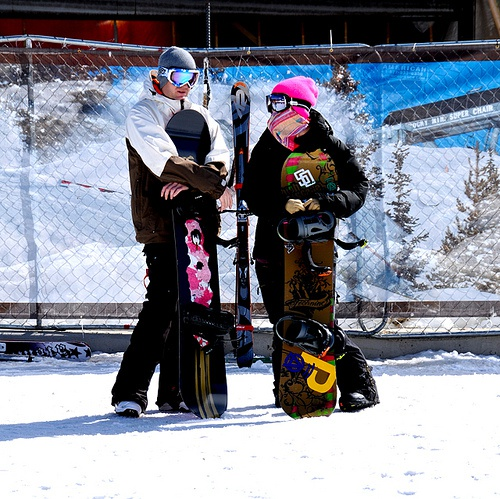Describe the objects in this image and their specific colors. I can see people in black, maroon, gray, and lavender tones, people in black, lavender, navy, and darkgray tones, snowboard in black, maroon, orange, and navy tones, snowboard in black, gray, lavender, and olive tones, and skis in black, navy, gray, and maroon tones in this image. 